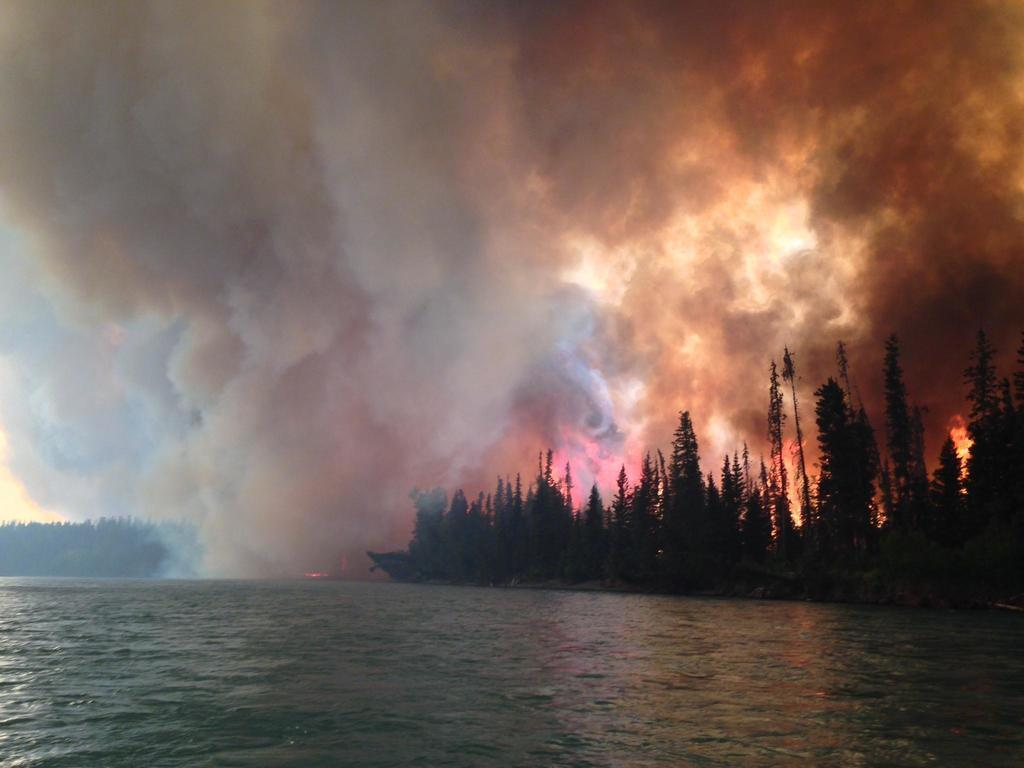What is happening in the forest in the image? There is fire in the forest in the image. What can be seen at the bottom of the image? There is a river visible at the bottom of the image. What type of vegetation is present on the right side of the image? There are many trees on the right side of the image. What is visible in the sky in the image? The sky is visible in the image. What is the result of the fire in the forest? There is smoke visible at the top of the image as a result of the fire. How many flowers are present in the image? There are no flowers mentioned or visible in the image. What type of minister is standing near the river in the image? There is no minister present in the image. 